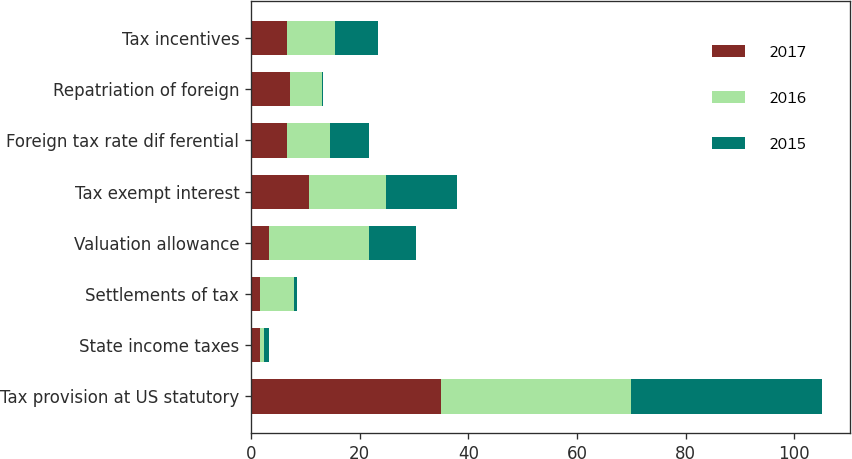Convert chart to OTSL. <chart><loc_0><loc_0><loc_500><loc_500><stacked_bar_chart><ecel><fcel>Tax provision at US statutory<fcel>State income taxes<fcel>Settlements of tax<fcel>Valuation allowance<fcel>Tax exempt interest<fcel>Foreign tax rate dif ferential<fcel>Repatriation of foreign<fcel>Tax incentives<nl><fcel>2017<fcel>35<fcel>1.6<fcel>1.6<fcel>3.3<fcel>10.6<fcel>6.7<fcel>7.2<fcel>6.6<nl><fcel>2016<fcel>35<fcel>0.8<fcel>6.4<fcel>18.5<fcel>14.3<fcel>7.9<fcel>5.9<fcel>8.9<nl><fcel>2015<fcel>35<fcel>1<fcel>0.5<fcel>8.6<fcel>13.1<fcel>7.2<fcel>0.2<fcel>7.8<nl></chart> 